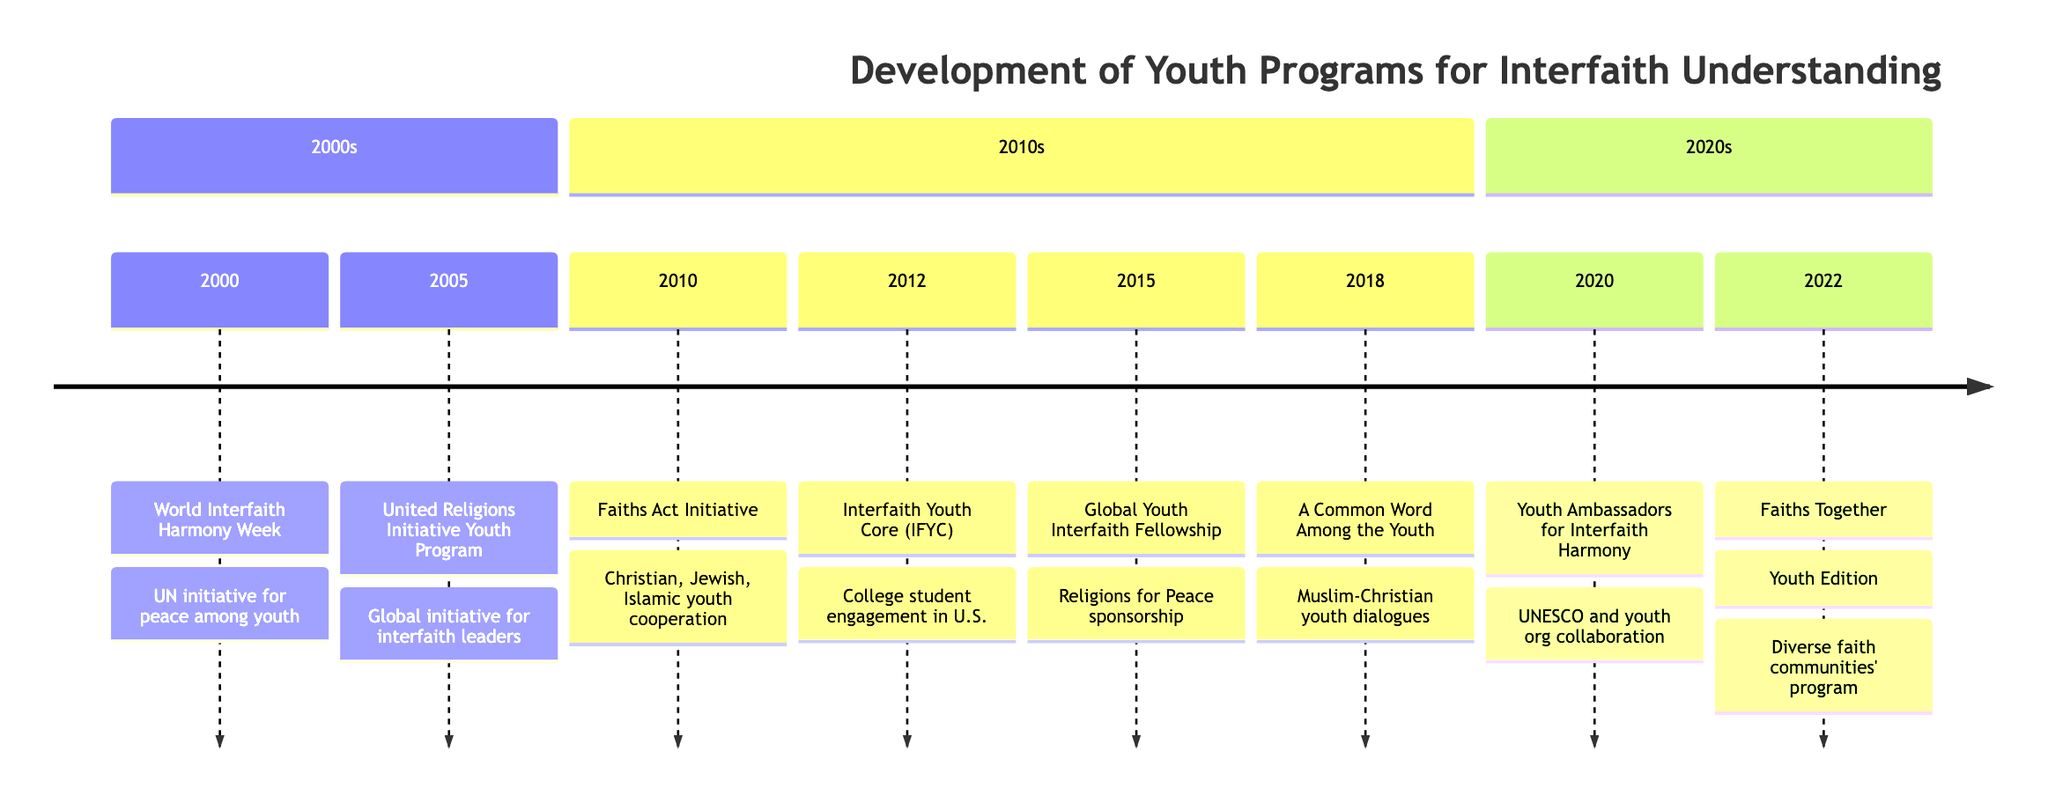What year was the World Interfaith Harmony Week initiated? The World Interfaith Harmony Week is listed in the timeline under the year 2000, indicating that this is when it was initiated.
Answer: 2000 How many youth programs are documented in the timeline? By counting each event in the timeline, there are a total of eight distinct youth programs detailed from 2000 to 2022.
Answer: 8 What is the main focus of the United Religions Initiative Youth Program? The description states that the United Religions Initiative Youth Program aims to bring young leaders from various faith backgrounds together, indicating its focus on collaboration and community-building.
Answer: Community-building projects Which initiative was launched in 2012? The timeline states that the Interfaith Youth Core (IFYC) was launched in the year 2012, making it the event recorded for that year.
Answer: Interfaith Youth Core (IFYC) What year did the Launch of Youth Ambassadors for Interfaith Harmony occur? The timeline specifically records the event "Launch of Youth Ambassadors for Interfaith Harmony" under the year 2020.
Answer: 2020 Which organizations collaborated for the Youth Ambassadors for Interfaith Harmony? The description indicates that this initiative was a collaborative effort between UNESCO and national youth organizations, showing the entities involved in this program.
Answer: UNESCO and national youth organizations What type of dialogue is promoted by "A Common Word Among the Youth"? The description reveals that it focuses on youth-led interfaith dialogues between Muslim and Christian communities, indicating the type of engagement it promotes.
Answer: Interfaith dialogues What is the purpose of the Global Youth Interfaith Fellowship Program? According to the timeline, this program is meant to offer fellowships for young adults to promote interfaith projects, indicating its purpose regarding interfaith initiatives in the community.
Answer: Promote interfaith projects 